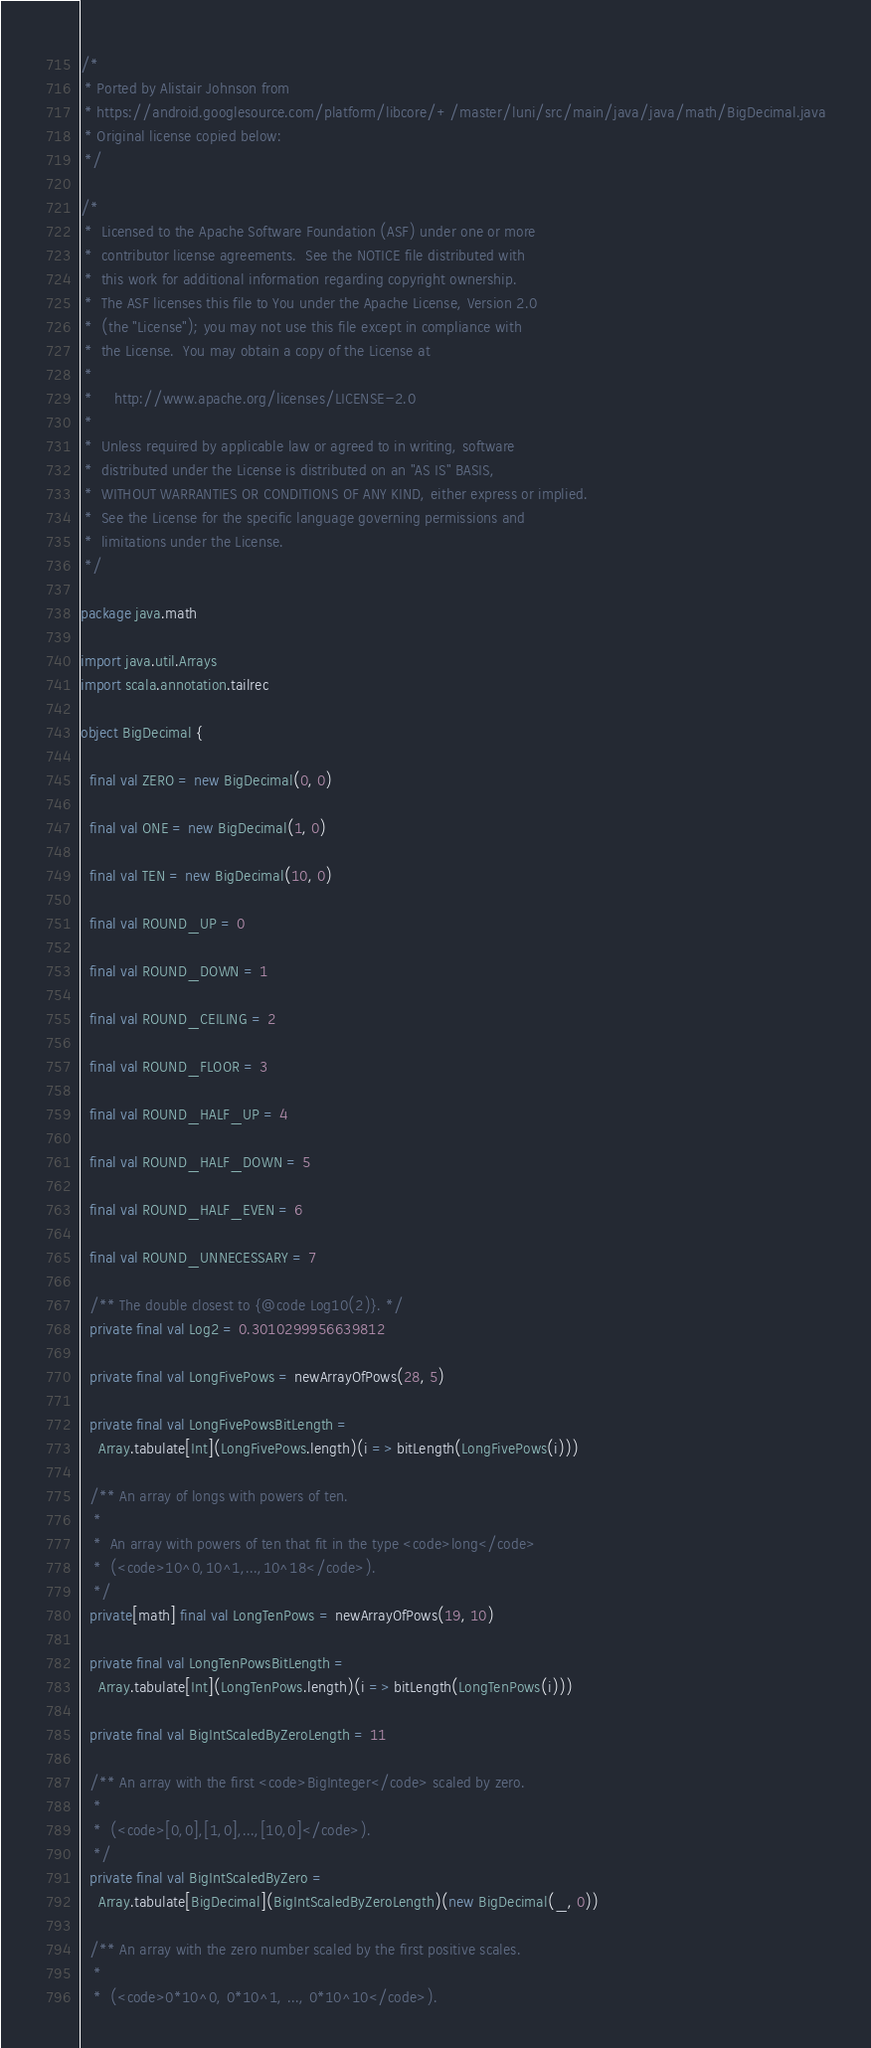Convert code to text. <code><loc_0><loc_0><loc_500><loc_500><_Scala_>/*
 * Ported by Alistair Johnson from
 * https://android.googlesource.com/platform/libcore/+/master/luni/src/main/java/java/math/BigDecimal.java
 * Original license copied below:
 */

/*
 *  Licensed to the Apache Software Foundation (ASF) under one or more
 *  contributor license agreements.  See the NOTICE file distributed with
 *  this work for additional information regarding copyright ownership.
 *  The ASF licenses this file to You under the Apache License, Version 2.0
 *  (the "License"); you may not use this file except in compliance with
 *  the License.  You may obtain a copy of the License at
 *
 *     http://www.apache.org/licenses/LICENSE-2.0
 *
 *  Unless required by applicable law or agreed to in writing, software
 *  distributed under the License is distributed on an "AS IS" BASIS,
 *  WITHOUT WARRANTIES OR CONDITIONS OF ANY KIND, either express or implied.
 *  See the License for the specific language governing permissions and
 *  limitations under the License.
 */

package java.math

import java.util.Arrays
import scala.annotation.tailrec

object BigDecimal {

  final val ZERO = new BigDecimal(0, 0)

  final val ONE = new BigDecimal(1, 0)

  final val TEN = new BigDecimal(10, 0)

  final val ROUND_UP = 0

  final val ROUND_DOWN = 1

  final val ROUND_CEILING = 2

  final val ROUND_FLOOR = 3

  final val ROUND_HALF_UP = 4

  final val ROUND_HALF_DOWN = 5

  final val ROUND_HALF_EVEN = 6

  final val ROUND_UNNECESSARY = 7

  /** The double closest to {@code Log10(2)}. */
  private final val Log2 = 0.3010299956639812

  private final val LongFivePows = newArrayOfPows(28, 5)

  private final val LongFivePowsBitLength =
    Array.tabulate[Int](LongFivePows.length)(i => bitLength(LongFivePows(i)))

  /** An array of longs with powers of ten.
   *
   *  An array with powers of ten that fit in the type <code>long</code>
   *  (<code>10^0,10^1,...,10^18</code>).
   */
  private[math] final val LongTenPows = newArrayOfPows(19, 10)

  private final val LongTenPowsBitLength =
    Array.tabulate[Int](LongTenPows.length)(i => bitLength(LongTenPows(i)))

  private final val BigIntScaledByZeroLength = 11

  /** An array with the first <code>BigInteger</code> scaled by zero.
   *
   *  (<code>[0,0],[1,0],...,[10,0]</code>).
   */
  private final val BigIntScaledByZero =
    Array.tabulate[BigDecimal](BigIntScaledByZeroLength)(new BigDecimal(_, 0))

  /** An array with the zero number scaled by the first positive scales.
   *
   *  (<code>0*10^0, 0*10^1, ..., 0*10^10</code>).</code> 